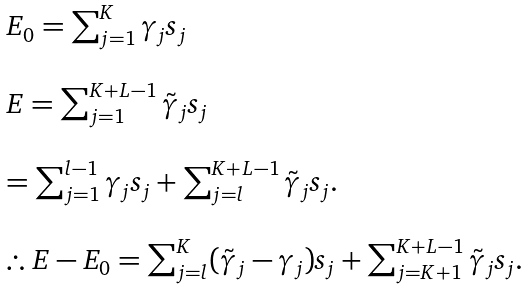<formula> <loc_0><loc_0><loc_500><loc_500>\begin{array} { l } E _ { 0 } = \sum _ { j = 1 } ^ { K } \gamma _ { j } s _ { j } \\ \\ E = \sum _ { j = 1 } ^ { K + L - 1 } \tilde { \gamma } _ { j } s _ { j } \\ \\ = \sum _ { j = 1 } ^ { l - 1 } \gamma _ { j } s _ { j } + \sum _ { j = l } ^ { K + L - 1 } \tilde { \gamma } _ { j } s _ { j } . \\ \\ \therefore E - E _ { 0 } = \sum _ { j = l } ^ { K } ( \tilde { \gamma } _ { j } - \gamma _ { j } ) s _ { j } + \sum _ { j = K + 1 } ^ { K + L - 1 } \tilde { \gamma } _ { j } s _ { j } . \end{array}</formula> 